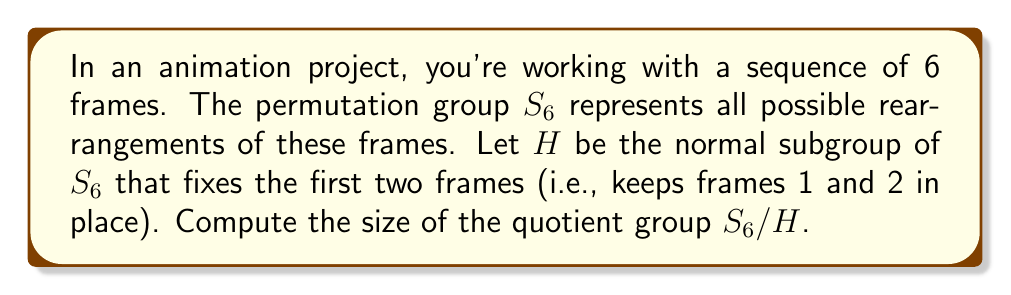Teach me how to tackle this problem. To solve this problem, we'll follow these steps:

1) First, we need to understand what the subgroup $H$ represents. It consists of all permutations in $S_6$ that keep the first two elements fixed. This means $H$ is isomorphic to $S_4$, as it permutes only the last 4 elements.

2) The size of $H$ is therefore $|H| = 4! = 24$.

3) We know that $|S_6| = 6! = 720$.

4) The Lagrange theorem states that for a group $G$ and its subgroup $H$:

   $$|G| = |G/H| \cdot |H|$$

   where $|G/H|$ is the size of the quotient group.

5) Rearranging this equation, we get:

   $$|G/H| = \frac{|G|}{|H|}$$

6) Substituting the values we know:

   $$|S_6/H| = \frac{|S_6|}{|H|} = \frac{720}{24} = 30$$

Therefore, the size of the quotient group $S_6/H$ is 30.

This result can be interpreted in the context of animation as the number of ways to rearrange the last 4 frames while keeping the first two fixed, considering these rearrangements as distinct classes of permutations.
Answer: The size of the quotient group $S_6/H$ is 30. 